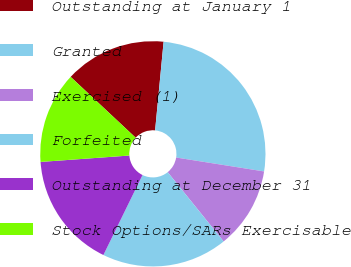Convert chart. <chart><loc_0><loc_0><loc_500><loc_500><pie_chart><fcel>Outstanding at January 1<fcel>Granted<fcel>Exercised (1)<fcel>Forfeited<fcel>Outstanding at December 31<fcel>Stock Options/SARs Exercisable<nl><fcel>14.55%<fcel>25.98%<fcel>11.69%<fcel>18.05%<fcel>16.62%<fcel>13.12%<nl></chart> 